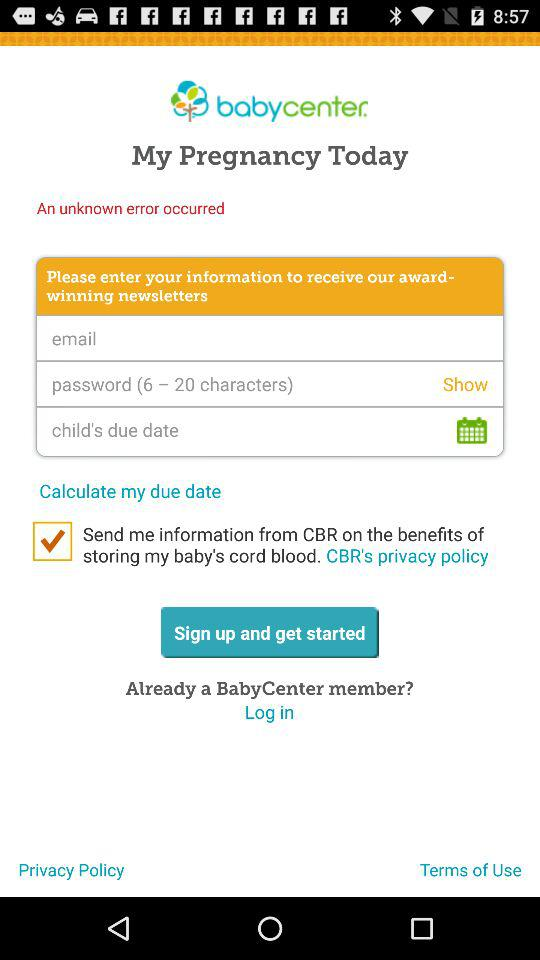How many input fields are there for signing up?
Answer the question using a single word or phrase. 3 